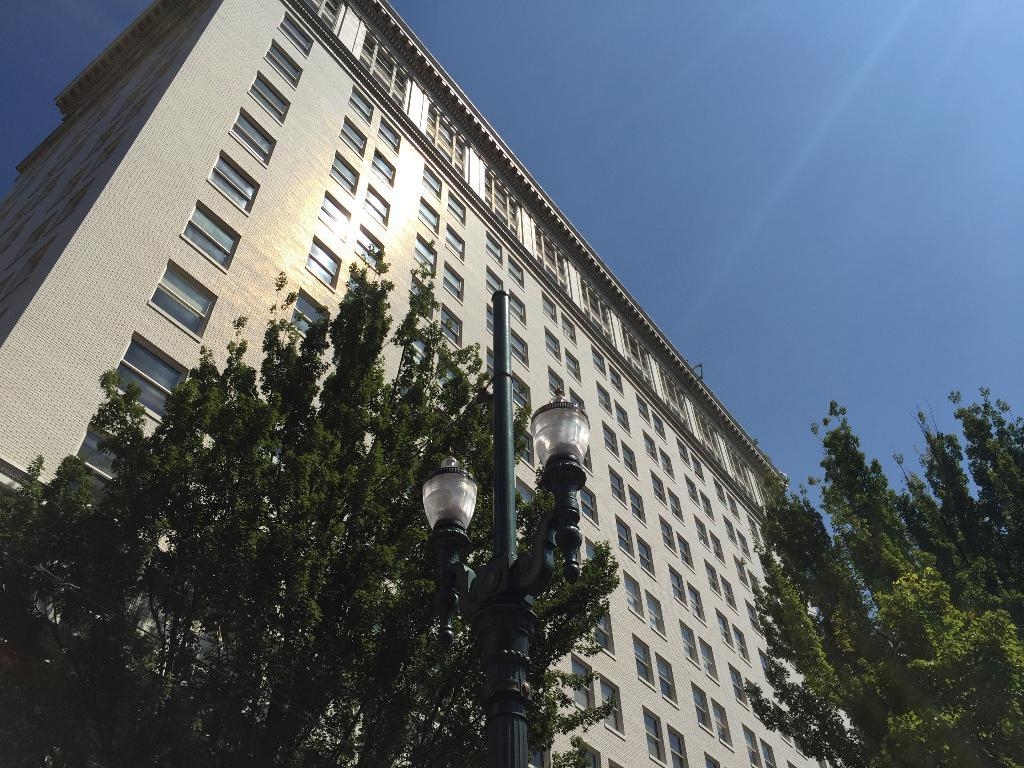What type of structure is visible in the image? There is a building in the image. What other natural elements can be seen in the image? There are trees in the image. What object is present in the image that might be used for support or signage? There is a pole in the image. What can be seen illuminating the area in the image? There are lights in the image. What is visible in the background of the image? The sky is visible in the background of the image. Reasoning: Let's think step by step by following the guidelines provided. We start by identifying the main subjects and objects in the image based on the provided facts. We then formulate questions that focus on the location and characteristics of these subjects and objects, ensuring that each question can be answered definitively with the information given. We avoid yes/no questions and ensure that the language is simple and clear. Absurd Question/Answer: Can you hear the ghost in the image? There is no ghost present in the image, so it is not possible to hear one. How many tails can be seen on the animals in the image? There are no animals present in the image, so it is not possible to count their tails. 